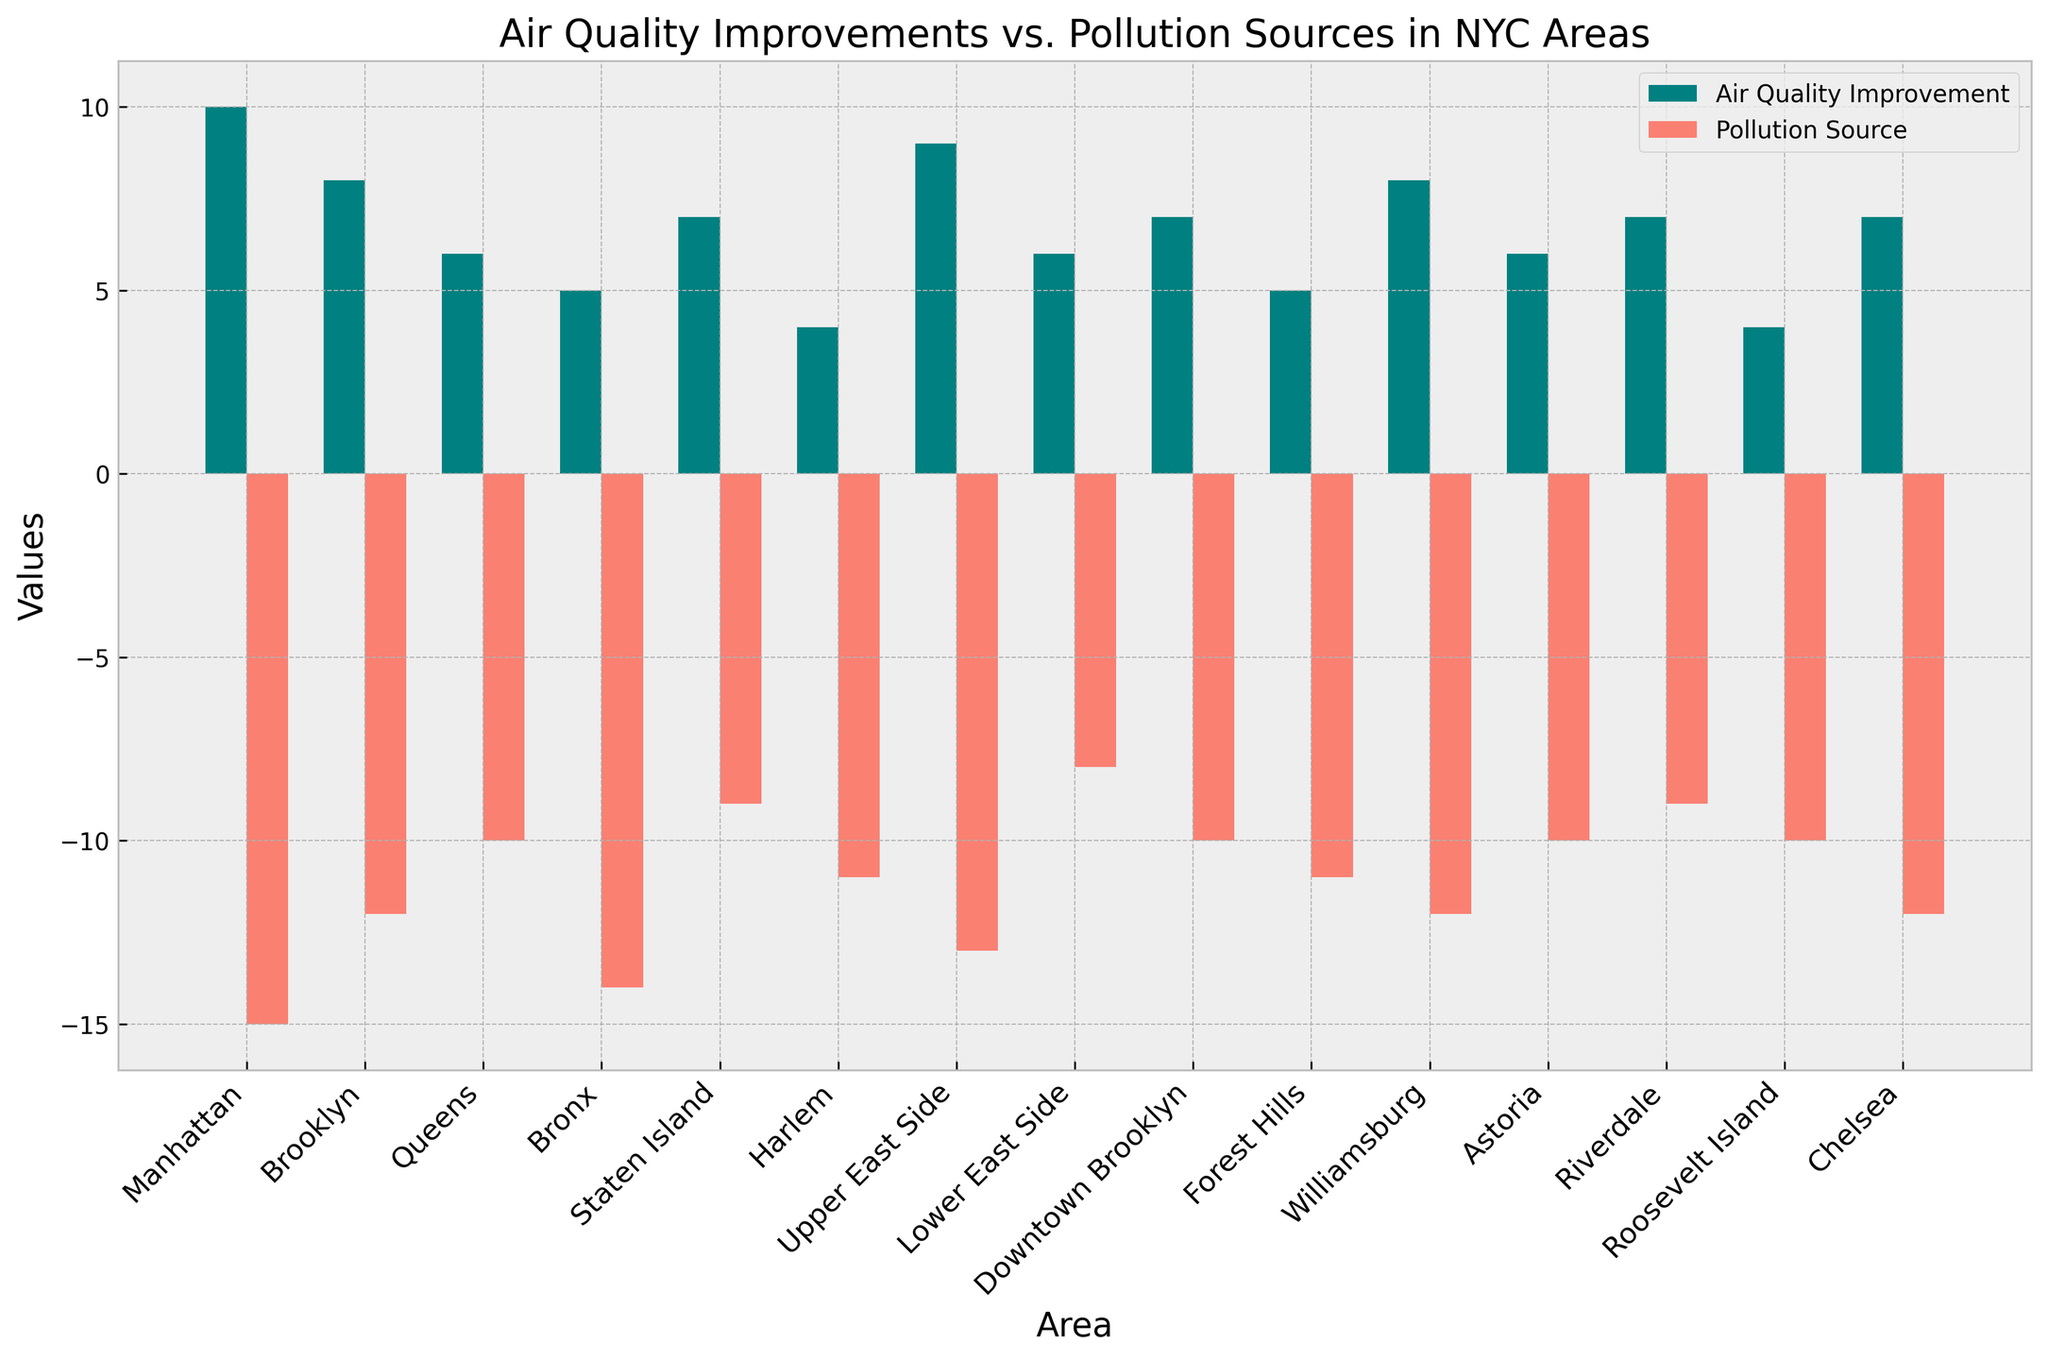Which area has the highest air quality improvement? By looking at the height of the positive bars, we see that the longest bar represents Manhattan with a height of 10.
Answer: Manhattan Which area has the highest pollution source? By looking at the height of the negative bars, we see that the longest bar represents Manhattan with a height of -15.
Answer: Manhattan Compare the air quality improvement between Brooklyn and Queens. Which one is higher? By comparing the height of the positive bars, Brooklyn has a height of 8 and Queens 6. Thus, Brooklyn has a higher improvement.
Answer: Brooklyn Compare the pollution source between Harlem and Riverdale. Which area has a lower pollution source? By comparing the height of the negative bars, Harlem has a height of -11 and Riverdale -9. Thus, Riverdale has a lower pollution source.
Answer: Riverdale What is the sum of air quality improvements in Bronx and Staten Island? Adding the positive values for Bronx (5) and Staten Island (7) gives 5 + 7 = 12.
Answer: 12 What is the combined total of air quality improvements and pollution sources for Roosevelt Island? Adding the positive (4) and the negative value (-10) gives 4 + (-10) = -6.
Answer: -6 Which has better air quality improvement, Downtown Brooklyn or Forest Hills? By comparing the positive bars, Downtown Brooklyn has a height of 7, and Forest Hills has a height of 5. Downtown Brooklyn has better air quality improvement.
Answer: Downtown Brooklyn What is the average air quality improvement across all areas? Sum of all improvements: 10 + 8 + 6 + 5 + 7 + 4 + 9 + 6 + 7 + 5 + 8 + 6 + 7 + 4 + 7 = 99. Number of areas is 15. So, the average is 99 / 15 ≈ 6.6
Answer: 6.6 Compare the pollution sources between Brooklyn and Williamsburg. Which one is less? Brooklyn's pollution source is -12, and Williamsburg's is also -12. They are equal.
Answer: Equal 